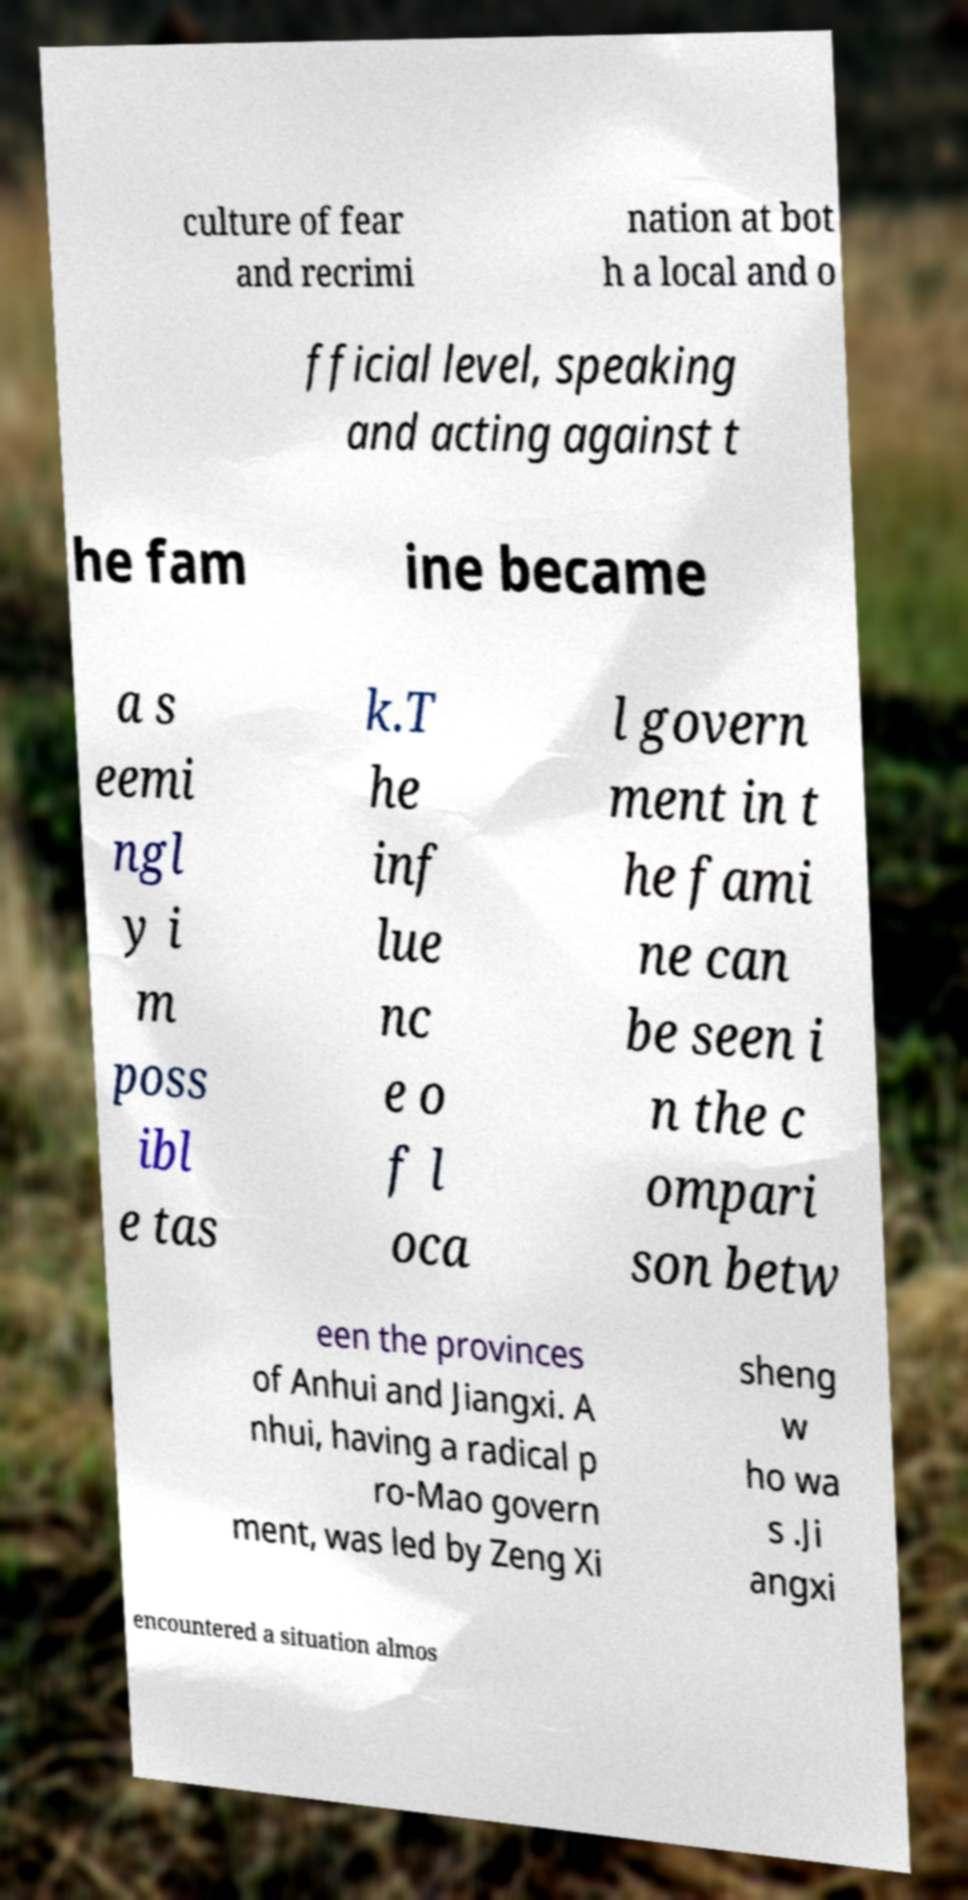What messages or text are displayed in this image? I need them in a readable, typed format. culture of fear and recrimi nation at bot h a local and o fficial level, speaking and acting against t he fam ine became a s eemi ngl y i m poss ibl e tas k.T he inf lue nc e o f l oca l govern ment in t he fami ne can be seen i n the c ompari son betw een the provinces of Anhui and Jiangxi. A nhui, having a radical p ro-Mao govern ment, was led by Zeng Xi sheng w ho wa s .Ji angxi encountered a situation almos 